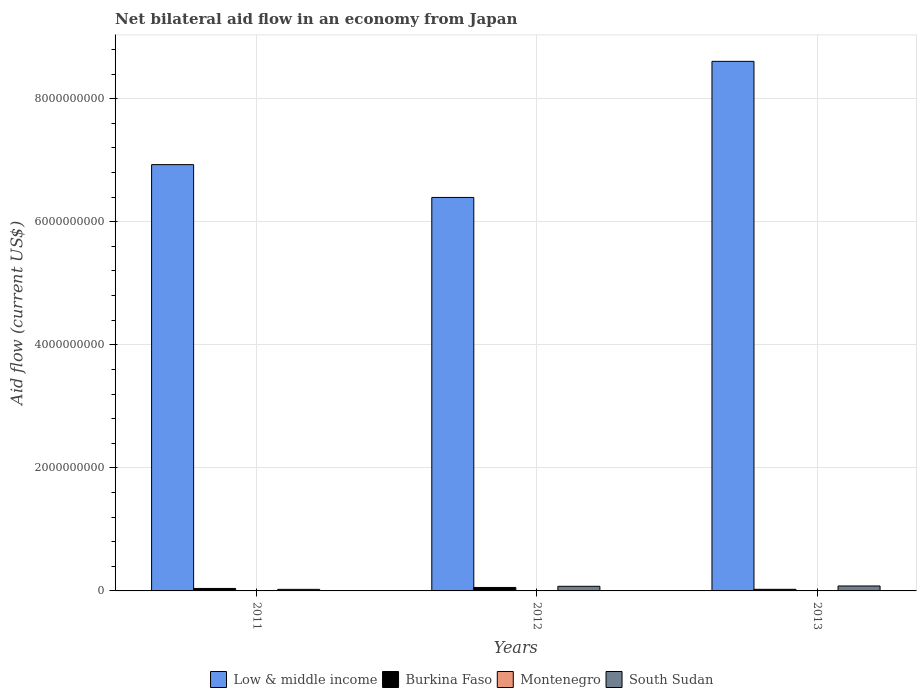Are the number of bars on each tick of the X-axis equal?
Provide a succinct answer. Yes. In how many cases, is the number of bars for a given year not equal to the number of legend labels?
Ensure brevity in your answer.  0. What is the net bilateral aid flow in Montenegro in 2011?
Your response must be concise. 4.67e+06. Across all years, what is the maximum net bilateral aid flow in Burkina Faso?
Provide a short and direct response. 5.64e+07. Across all years, what is the minimum net bilateral aid flow in South Sudan?
Offer a terse response. 2.56e+07. What is the total net bilateral aid flow in Low & middle income in the graph?
Your response must be concise. 2.19e+1. What is the difference between the net bilateral aid flow in Low & middle income in 2011 and that in 2012?
Keep it short and to the point. 5.33e+08. What is the difference between the net bilateral aid flow in Burkina Faso in 2011 and the net bilateral aid flow in Montenegro in 2012?
Your answer should be very brief. 3.92e+07. What is the average net bilateral aid flow in Montenegro per year?
Your answer should be very brief. 2.14e+06. In the year 2012, what is the difference between the net bilateral aid flow in Low & middle income and net bilateral aid flow in Burkina Faso?
Make the answer very short. 6.34e+09. What is the ratio of the net bilateral aid flow in Burkina Faso in 2011 to that in 2013?
Make the answer very short. 1.55. Is the net bilateral aid flow in Montenegro in 2011 less than that in 2013?
Make the answer very short. No. Is the difference between the net bilateral aid flow in Low & middle income in 2011 and 2012 greater than the difference between the net bilateral aid flow in Burkina Faso in 2011 and 2012?
Your response must be concise. Yes. What is the difference between the highest and the second highest net bilateral aid flow in Montenegro?
Provide a short and direct response. 3.53e+06. What is the difference between the highest and the lowest net bilateral aid flow in Low & middle income?
Offer a very short reply. 2.21e+09. What does the 4th bar from the left in 2011 represents?
Your answer should be very brief. South Sudan. What does the 3rd bar from the right in 2012 represents?
Keep it short and to the point. Burkina Faso. Are all the bars in the graph horizontal?
Give a very brief answer. No. How many years are there in the graph?
Ensure brevity in your answer.  3. What is the difference between two consecutive major ticks on the Y-axis?
Your answer should be compact. 2.00e+09. Are the values on the major ticks of Y-axis written in scientific E-notation?
Ensure brevity in your answer.  No. Does the graph contain grids?
Ensure brevity in your answer.  Yes. Where does the legend appear in the graph?
Give a very brief answer. Bottom center. What is the title of the graph?
Your response must be concise. Net bilateral aid flow in an economy from Japan. Does "Liberia" appear as one of the legend labels in the graph?
Your response must be concise. No. What is the Aid flow (current US$) in Low & middle income in 2011?
Make the answer very short. 6.93e+09. What is the Aid flow (current US$) of Burkina Faso in 2011?
Give a very brief answer. 4.03e+07. What is the Aid flow (current US$) of Montenegro in 2011?
Make the answer very short. 4.67e+06. What is the Aid flow (current US$) in South Sudan in 2011?
Provide a short and direct response. 2.56e+07. What is the Aid flow (current US$) in Low & middle income in 2012?
Offer a very short reply. 6.39e+09. What is the Aid flow (current US$) in Burkina Faso in 2012?
Ensure brevity in your answer.  5.64e+07. What is the Aid flow (current US$) in Montenegro in 2012?
Offer a very short reply. 1.14e+06. What is the Aid flow (current US$) of South Sudan in 2012?
Your answer should be compact. 7.50e+07. What is the Aid flow (current US$) in Low & middle income in 2013?
Give a very brief answer. 8.61e+09. What is the Aid flow (current US$) of Burkina Faso in 2013?
Your answer should be very brief. 2.61e+07. What is the Aid flow (current US$) of South Sudan in 2013?
Provide a short and direct response. 8.04e+07. Across all years, what is the maximum Aid flow (current US$) of Low & middle income?
Give a very brief answer. 8.61e+09. Across all years, what is the maximum Aid flow (current US$) in Burkina Faso?
Provide a succinct answer. 5.64e+07. Across all years, what is the maximum Aid flow (current US$) in Montenegro?
Provide a succinct answer. 4.67e+06. Across all years, what is the maximum Aid flow (current US$) in South Sudan?
Provide a succinct answer. 8.04e+07. Across all years, what is the minimum Aid flow (current US$) of Low & middle income?
Offer a very short reply. 6.39e+09. Across all years, what is the minimum Aid flow (current US$) in Burkina Faso?
Your response must be concise. 2.61e+07. Across all years, what is the minimum Aid flow (current US$) of South Sudan?
Ensure brevity in your answer.  2.56e+07. What is the total Aid flow (current US$) in Low & middle income in the graph?
Keep it short and to the point. 2.19e+1. What is the total Aid flow (current US$) in Burkina Faso in the graph?
Provide a succinct answer. 1.23e+08. What is the total Aid flow (current US$) in Montenegro in the graph?
Your answer should be very brief. 6.41e+06. What is the total Aid flow (current US$) of South Sudan in the graph?
Offer a terse response. 1.81e+08. What is the difference between the Aid flow (current US$) of Low & middle income in 2011 and that in 2012?
Keep it short and to the point. 5.33e+08. What is the difference between the Aid flow (current US$) in Burkina Faso in 2011 and that in 2012?
Offer a terse response. -1.61e+07. What is the difference between the Aid flow (current US$) of Montenegro in 2011 and that in 2012?
Provide a short and direct response. 3.53e+06. What is the difference between the Aid flow (current US$) in South Sudan in 2011 and that in 2012?
Provide a short and direct response. -4.95e+07. What is the difference between the Aid flow (current US$) in Low & middle income in 2011 and that in 2013?
Provide a succinct answer. -1.68e+09. What is the difference between the Aid flow (current US$) of Burkina Faso in 2011 and that in 2013?
Provide a short and direct response. 1.42e+07. What is the difference between the Aid flow (current US$) in Montenegro in 2011 and that in 2013?
Keep it short and to the point. 4.07e+06. What is the difference between the Aid flow (current US$) of South Sudan in 2011 and that in 2013?
Provide a succinct answer. -5.48e+07. What is the difference between the Aid flow (current US$) of Low & middle income in 2012 and that in 2013?
Offer a terse response. -2.21e+09. What is the difference between the Aid flow (current US$) of Burkina Faso in 2012 and that in 2013?
Provide a short and direct response. 3.03e+07. What is the difference between the Aid flow (current US$) in Montenegro in 2012 and that in 2013?
Provide a short and direct response. 5.40e+05. What is the difference between the Aid flow (current US$) of South Sudan in 2012 and that in 2013?
Keep it short and to the point. -5.33e+06. What is the difference between the Aid flow (current US$) in Low & middle income in 2011 and the Aid flow (current US$) in Burkina Faso in 2012?
Offer a very short reply. 6.87e+09. What is the difference between the Aid flow (current US$) of Low & middle income in 2011 and the Aid flow (current US$) of Montenegro in 2012?
Ensure brevity in your answer.  6.93e+09. What is the difference between the Aid flow (current US$) of Low & middle income in 2011 and the Aid flow (current US$) of South Sudan in 2012?
Give a very brief answer. 6.85e+09. What is the difference between the Aid flow (current US$) in Burkina Faso in 2011 and the Aid flow (current US$) in Montenegro in 2012?
Give a very brief answer. 3.92e+07. What is the difference between the Aid flow (current US$) of Burkina Faso in 2011 and the Aid flow (current US$) of South Sudan in 2012?
Your answer should be compact. -3.47e+07. What is the difference between the Aid flow (current US$) of Montenegro in 2011 and the Aid flow (current US$) of South Sudan in 2012?
Give a very brief answer. -7.04e+07. What is the difference between the Aid flow (current US$) of Low & middle income in 2011 and the Aid flow (current US$) of Burkina Faso in 2013?
Make the answer very short. 6.90e+09. What is the difference between the Aid flow (current US$) in Low & middle income in 2011 and the Aid flow (current US$) in Montenegro in 2013?
Your response must be concise. 6.93e+09. What is the difference between the Aid flow (current US$) in Low & middle income in 2011 and the Aid flow (current US$) in South Sudan in 2013?
Your response must be concise. 6.85e+09. What is the difference between the Aid flow (current US$) of Burkina Faso in 2011 and the Aid flow (current US$) of Montenegro in 2013?
Make the answer very short. 3.97e+07. What is the difference between the Aid flow (current US$) of Burkina Faso in 2011 and the Aid flow (current US$) of South Sudan in 2013?
Ensure brevity in your answer.  -4.01e+07. What is the difference between the Aid flow (current US$) of Montenegro in 2011 and the Aid flow (current US$) of South Sudan in 2013?
Offer a terse response. -7.57e+07. What is the difference between the Aid flow (current US$) in Low & middle income in 2012 and the Aid flow (current US$) in Burkina Faso in 2013?
Provide a short and direct response. 6.37e+09. What is the difference between the Aid flow (current US$) in Low & middle income in 2012 and the Aid flow (current US$) in Montenegro in 2013?
Offer a very short reply. 6.39e+09. What is the difference between the Aid flow (current US$) in Low & middle income in 2012 and the Aid flow (current US$) in South Sudan in 2013?
Your response must be concise. 6.31e+09. What is the difference between the Aid flow (current US$) of Burkina Faso in 2012 and the Aid flow (current US$) of Montenegro in 2013?
Keep it short and to the point. 5.58e+07. What is the difference between the Aid flow (current US$) in Burkina Faso in 2012 and the Aid flow (current US$) in South Sudan in 2013?
Provide a succinct answer. -2.40e+07. What is the difference between the Aid flow (current US$) in Montenegro in 2012 and the Aid flow (current US$) in South Sudan in 2013?
Give a very brief answer. -7.92e+07. What is the average Aid flow (current US$) of Low & middle income per year?
Ensure brevity in your answer.  7.31e+09. What is the average Aid flow (current US$) of Burkina Faso per year?
Offer a very short reply. 4.09e+07. What is the average Aid flow (current US$) in Montenegro per year?
Offer a terse response. 2.14e+06. What is the average Aid flow (current US$) of South Sudan per year?
Your response must be concise. 6.03e+07. In the year 2011, what is the difference between the Aid flow (current US$) of Low & middle income and Aid flow (current US$) of Burkina Faso?
Your response must be concise. 6.89e+09. In the year 2011, what is the difference between the Aid flow (current US$) in Low & middle income and Aid flow (current US$) in Montenegro?
Your answer should be compact. 6.92e+09. In the year 2011, what is the difference between the Aid flow (current US$) in Low & middle income and Aid flow (current US$) in South Sudan?
Give a very brief answer. 6.90e+09. In the year 2011, what is the difference between the Aid flow (current US$) in Burkina Faso and Aid flow (current US$) in Montenegro?
Make the answer very short. 3.56e+07. In the year 2011, what is the difference between the Aid flow (current US$) of Burkina Faso and Aid flow (current US$) of South Sudan?
Your answer should be very brief. 1.47e+07. In the year 2011, what is the difference between the Aid flow (current US$) of Montenegro and Aid flow (current US$) of South Sudan?
Provide a short and direct response. -2.09e+07. In the year 2012, what is the difference between the Aid flow (current US$) of Low & middle income and Aid flow (current US$) of Burkina Faso?
Your answer should be compact. 6.34e+09. In the year 2012, what is the difference between the Aid flow (current US$) in Low & middle income and Aid flow (current US$) in Montenegro?
Your answer should be very brief. 6.39e+09. In the year 2012, what is the difference between the Aid flow (current US$) of Low & middle income and Aid flow (current US$) of South Sudan?
Your answer should be very brief. 6.32e+09. In the year 2012, what is the difference between the Aid flow (current US$) in Burkina Faso and Aid flow (current US$) in Montenegro?
Give a very brief answer. 5.52e+07. In the year 2012, what is the difference between the Aid flow (current US$) in Burkina Faso and Aid flow (current US$) in South Sudan?
Give a very brief answer. -1.87e+07. In the year 2012, what is the difference between the Aid flow (current US$) in Montenegro and Aid flow (current US$) in South Sudan?
Provide a short and direct response. -7.39e+07. In the year 2013, what is the difference between the Aid flow (current US$) in Low & middle income and Aid flow (current US$) in Burkina Faso?
Ensure brevity in your answer.  8.58e+09. In the year 2013, what is the difference between the Aid flow (current US$) in Low & middle income and Aid flow (current US$) in Montenegro?
Make the answer very short. 8.61e+09. In the year 2013, what is the difference between the Aid flow (current US$) of Low & middle income and Aid flow (current US$) of South Sudan?
Ensure brevity in your answer.  8.53e+09. In the year 2013, what is the difference between the Aid flow (current US$) of Burkina Faso and Aid flow (current US$) of Montenegro?
Your answer should be very brief. 2.55e+07. In the year 2013, what is the difference between the Aid flow (current US$) of Burkina Faso and Aid flow (current US$) of South Sudan?
Give a very brief answer. -5.43e+07. In the year 2013, what is the difference between the Aid flow (current US$) of Montenegro and Aid flow (current US$) of South Sudan?
Keep it short and to the point. -7.98e+07. What is the ratio of the Aid flow (current US$) in Low & middle income in 2011 to that in 2012?
Offer a terse response. 1.08. What is the ratio of the Aid flow (current US$) in Burkina Faso in 2011 to that in 2012?
Provide a short and direct response. 0.71. What is the ratio of the Aid flow (current US$) in Montenegro in 2011 to that in 2012?
Offer a very short reply. 4.1. What is the ratio of the Aid flow (current US$) of South Sudan in 2011 to that in 2012?
Offer a very short reply. 0.34. What is the ratio of the Aid flow (current US$) in Low & middle income in 2011 to that in 2013?
Your response must be concise. 0.81. What is the ratio of the Aid flow (current US$) of Burkina Faso in 2011 to that in 2013?
Keep it short and to the point. 1.55. What is the ratio of the Aid flow (current US$) in Montenegro in 2011 to that in 2013?
Offer a very short reply. 7.78. What is the ratio of the Aid flow (current US$) in South Sudan in 2011 to that in 2013?
Offer a very short reply. 0.32. What is the ratio of the Aid flow (current US$) of Low & middle income in 2012 to that in 2013?
Offer a very short reply. 0.74. What is the ratio of the Aid flow (current US$) in Burkina Faso in 2012 to that in 2013?
Provide a short and direct response. 2.16. What is the ratio of the Aid flow (current US$) in South Sudan in 2012 to that in 2013?
Provide a succinct answer. 0.93. What is the difference between the highest and the second highest Aid flow (current US$) in Low & middle income?
Your answer should be very brief. 1.68e+09. What is the difference between the highest and the second highest Aid flow (current US$) in Burkina Faso?
Provide a succinct answer. 1.61e+07. What is the difference between the highest and the second highest Aid flow (current US$) of Montenegro?
Ensure brevity in your answer.  3.53e+06. What is the difference between the highest and the second highest Aid flow (current US$) of South Sudan?
Your answer should be very brief. 5.33e+06. What is the difference between the highest and the lowest Aid flow (current US$) in Low & middle income?
Offer a terse response. 2.21e+09. What is the difference between the highest and the lowest Aid flow (current US$) of Burkina Faso?
Your answer should be compact. 3.03e+07. What is the difference between the highest and the lowest Aid flow (current US$) of Montenegro?
Keep it short and to the point. 4.07e+06. What is the difference between the highest and the lowest Aid flow (current US$) in South Sudan?
Offer a terse response. 5.48e+07. 